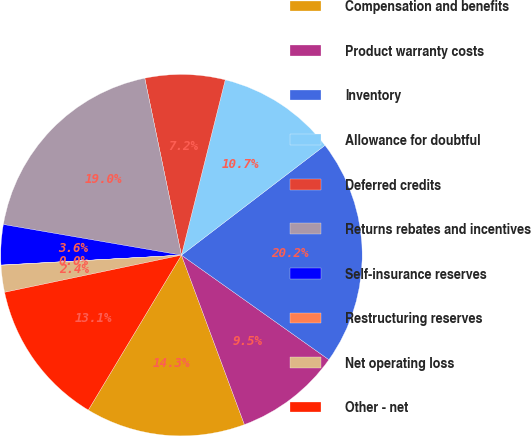<chart> <loc_0><loc_0><loc_500><loc_500><pie_chart><fcel>Compensation and benefits<fcel>Product warranty costs<fcel>Inventory<fcel>Allowance for doubtful<fcel>Deferred credits<fcel>Returns rebates and incentives<fcel>Self-insurance reserves<fcel>Restructuring reserves<fcel>Net operating loss<fcel>Other - net<nl><fcel>14.28%<fcel>9.52%<fcel>20.21%<fcel>10.71%<fcel>7.15%<fcel>19.03%<fcel>3.59%<fcel>0.02%<fcel>2.4%<fcel>13.09%<nl></chart> 